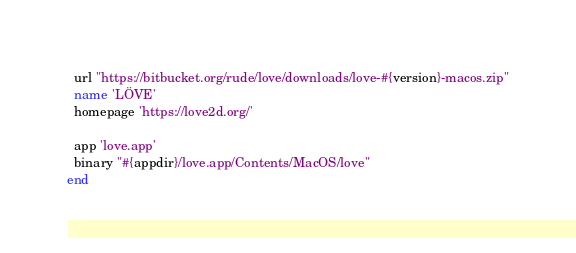Convert code to text. <code><loc_0><loc_0><loc_500><loc_500><_Ruby_>  url "https://bitbucket.org/rude/love/downloads/love-#{version}-macos.zip"
  name 'LÖVE'
  homepage 'https://love2d.org/'

  app 'love.app'
  binary "#{appdir}/love.app/Contents/MacOS/love"
end
</code> 